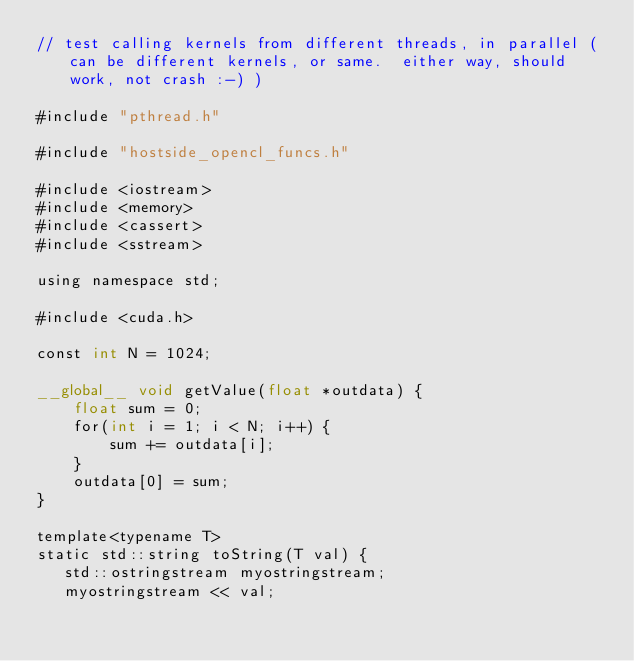Convert code to text. <code><loc_0><loc_0><loc_500><loc_500><_Cuda_>// test calling kernels from different threads, in parallel (can be different kernels, or same.  either way, should work, not crash :-) )

#include "pthread.h"

#include "hostside_opencl_funcs.h"

#include <iostream>
#include <memory>
#include <cassert>
#include <sstream>

using namespace std;

#include <cuda.h>

const int N = 1024;

__global__ void getValue(float *outdata) {
    float sum = 0;
    for(int i = 1; i < N; i++) {
        sum += outdata[i];
    }
    outdata[0] = sum;
}

template<typename T>
static std::string toString(T val) {
   std::ostringstream myostringstream;
   myostringstream << val;</code> 